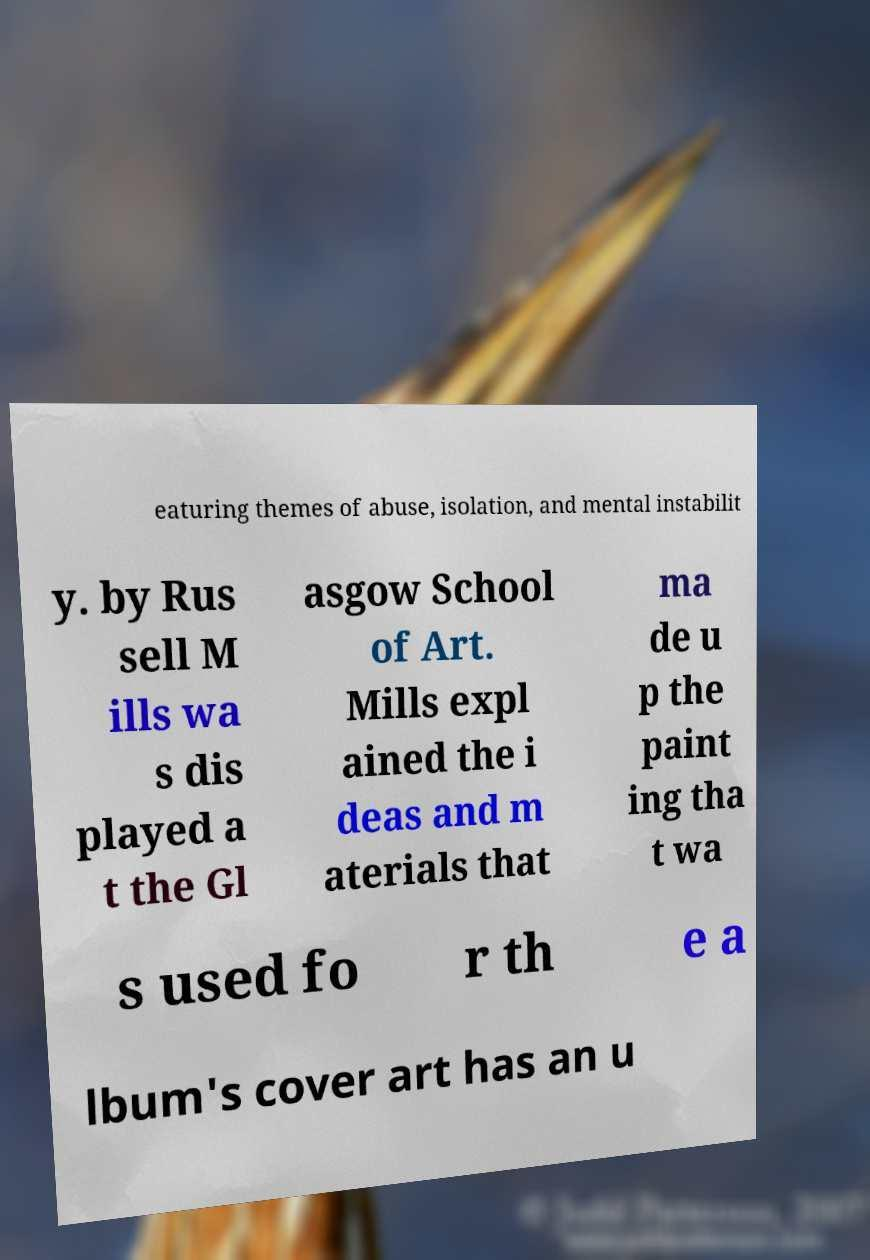What messages or text are displayed in this image? I need them in a readable, typed format. eaturing themes of abuse, isolation, and mental instabilit y. by Rus sell M ills wa s dis played a t the Gl asgow School of Art. Mills expl ained the i deas and m aterials that ma de u p the paint ing tha t wa s used fo r th e a lbum's cover art has an u 